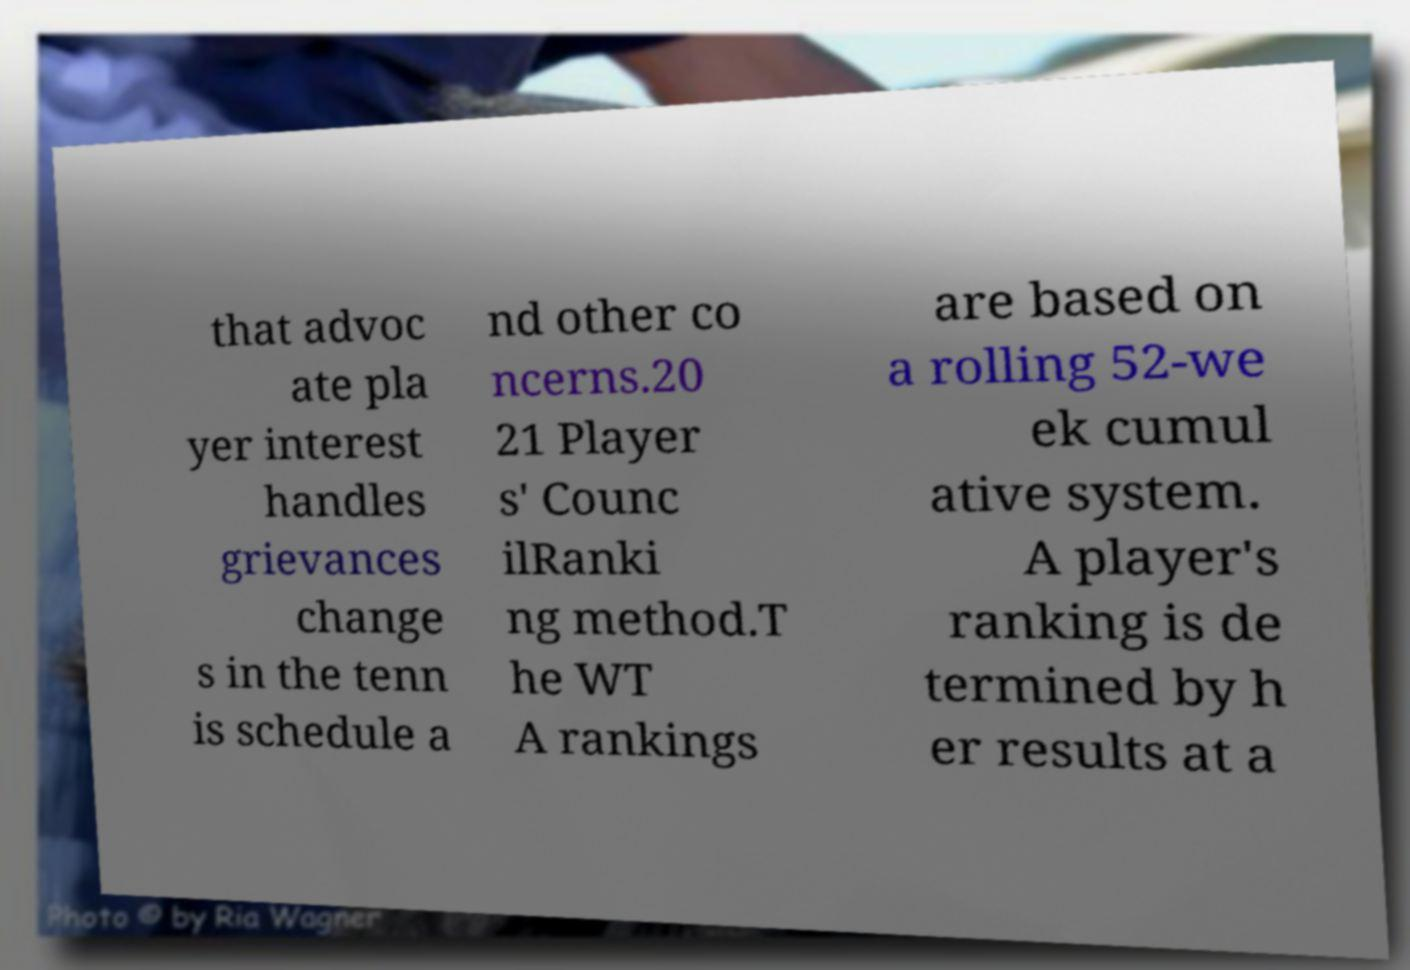Could you extract and type out the text from this image? that advoc ate pla yer interest handles grievances change s in the tenn is schedule a nd other co ncerns.20 21 Player s' Counc ilRanki ng method.T he WT A rankings are based on a rolling 52-we ek cumul ative system. A player's ranking is de termined by h er results at a 